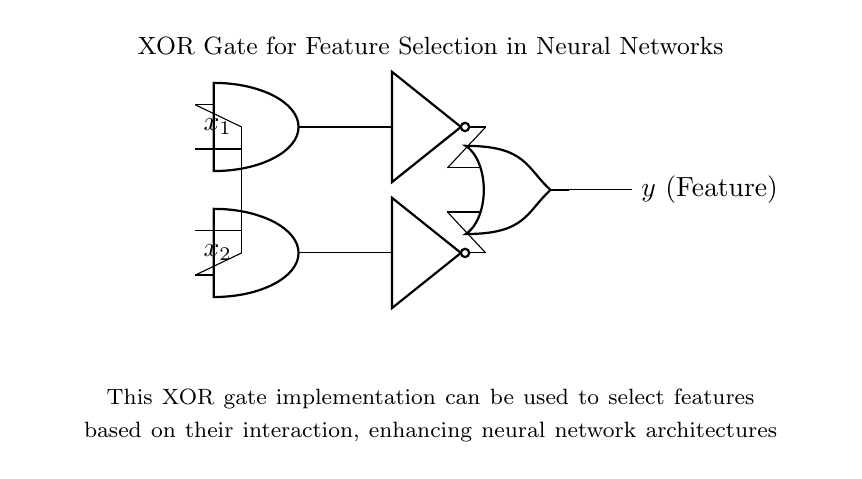What type of gate is represented in the circuit? The circuit shows an XOR gate, which can be identified by its distinct shape and inputs/outputs.
Answer: XOR gate How many input variables does this circuit have? The circuit has two input variables, x1 and x2, as indicated by the two lines connecting to the AND gates.
Answer: Two What is the output of this circuit called? The output of the circuit is labeled as 'y', which represents the selected feature in the context of neural networks.
Answer: y Which components are used in this XOR gate? The circuit includes two AND gates, two NOT gates, and one OR gate, which are all connected to perform the XOR function.
Answer: AND, NOT, OR What role does the NOT gate play in this implementation? The NOT gate inverts the output from the AND gates, enabling the XOR function by negating one of the inputs before the OR operation.
Answer: Inversion How does this circuit enhance feature selection in neural networks? The XOR gate allows for evaluation of input feature interactions, enabling the model to focus on combinations of features that improve learning.
Answer: Interaction evaluation What is the function of the OR gate in this XOR implementation? The OR gate combines the outputs from the two NOT gates, producing a final output based on which input combinations are present, thus implementing the XOR logic.
Answer: Combination of outputs 